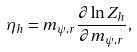Convert formula to latex. <formula><loc_0><loc_0><loc_500><loc_500>\eta _ { h } = m _ { \psi , r } \frac { \partial \ln Z _ { h } } { \partial m _ { \psi , r } } ,</formula> 